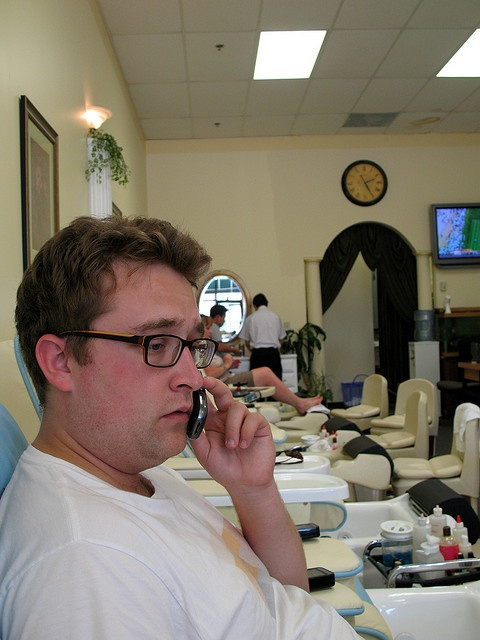Describe the objects in this image and their specific colors. I can see people in tan, brown, darkgray, black, and lightgray tones, dining table in tan, darkgray, black, gray, and lightgray tones, tv in tan, black, lightblue, darkgreen, and teal tones, chair in tan, darkgray, gray, and olive tones, and people in tan, darkgray, black, and gray tones in this image. 